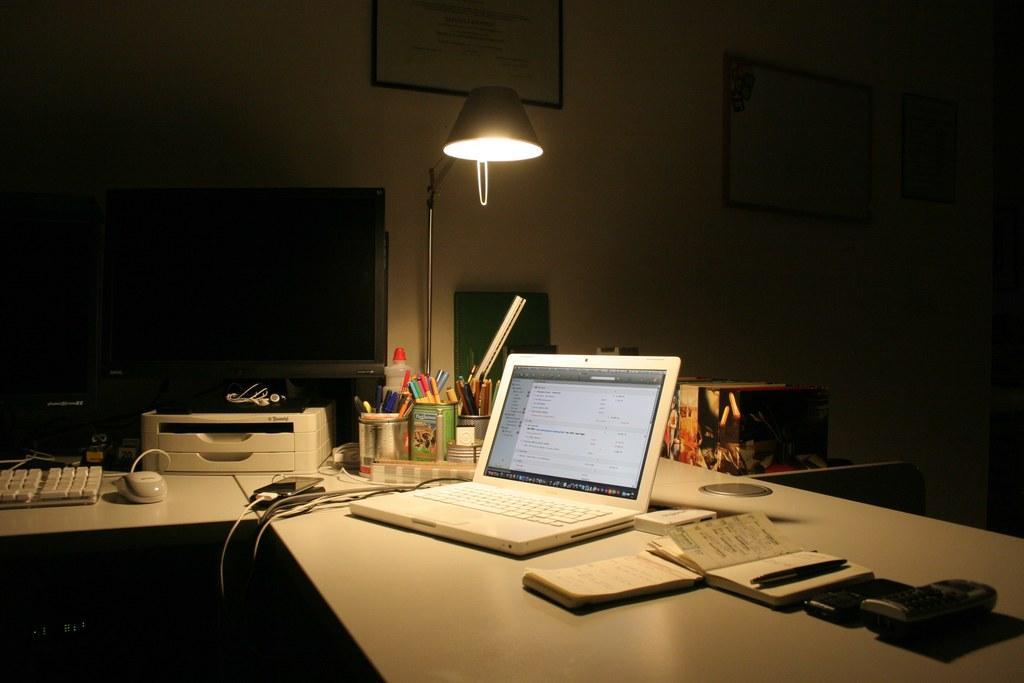Can you describe this image briefly? In this image I see a table on which there are 2 screens, a keyboard, a mouse, few pens, a laptop, books, a pen, a remote and other things and I can also see a lamp over here. In the background I see the wall and there are 3 frames on it. 